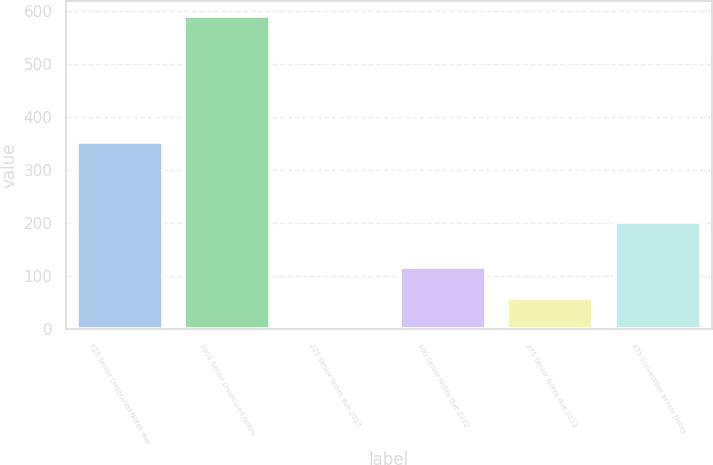Convert chart to OTSL. <chart><loc_0><loc_0><loc_500><loc_500><bar_chart><fcel>625 Senior Unsecured Notes due<fcel>1000 Senior Unsecured Notes<fcel>225 Senior Notes due 2017<fcel>400 Senior Notes due 2022<fcel>375 Senior Notes due 2023<fcel>475 Convertible Senior Notes<nl><fcel>354.3<fcel>590.6<fcel>0.23<fcel>118.31<fcel>59.27<fcel>202.7<nl></chart> 